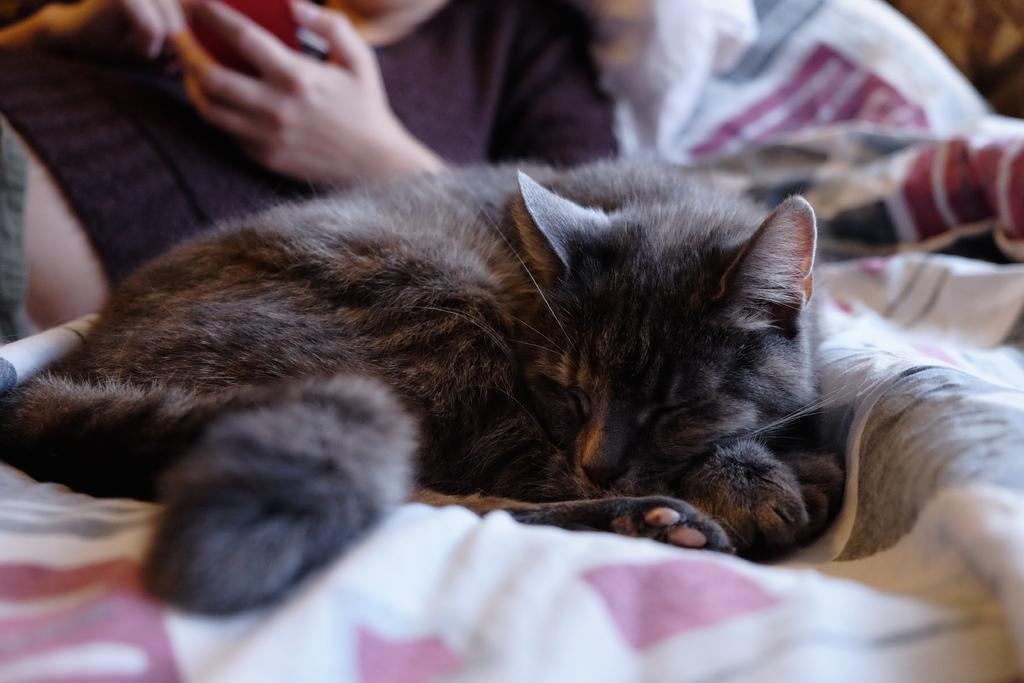How would you summarize this image in a sentence or two? In this image we can see a cat on the bed, also we can see a person. 